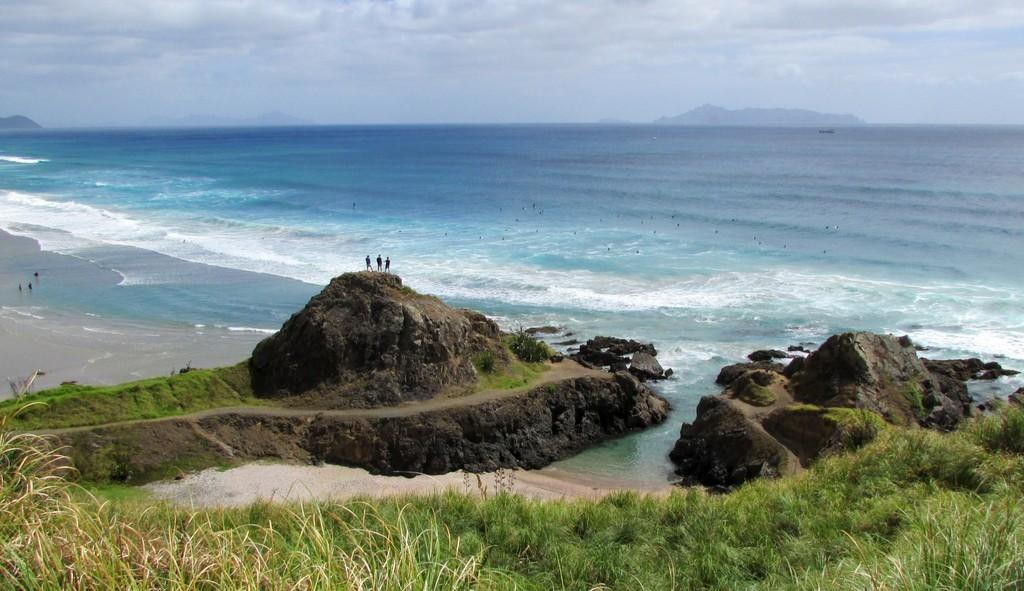What type of vegetation is present in the image? There is grass in the image. What other objects can be seen in the image? There are rocks in the image. Are there any people in the image? Yes, there are people standing near the rocks. What can be seen in the background of the image? Water, clouds, and the sky are visible in the background of the image. What type of pipe is being played by the people in the image? There is no pipe present in the image; the people are standing near rocks. How much profit can be made from the horn in the image? There is no horn present in the image, so it is not possible to determine any potential profit. 